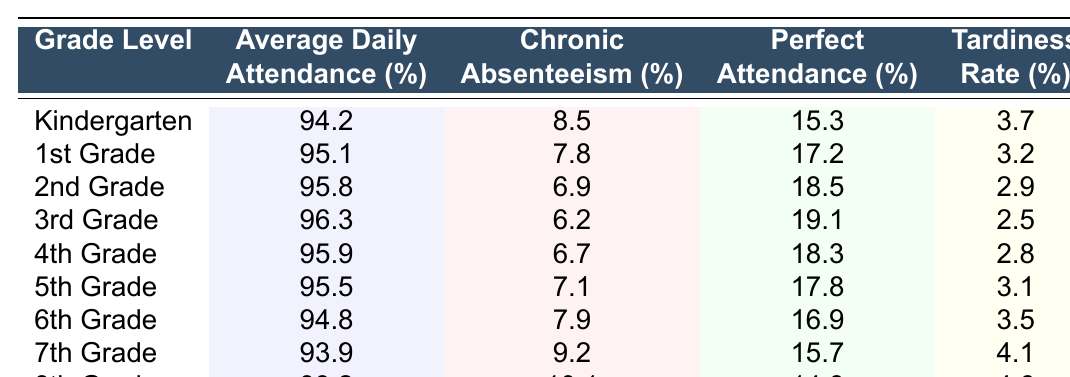What is the average daily attendance percentage for 3rd grade? The table shows that the average daily attendance for 3rd grade is listed directly under the “Average Daily Attendance (%)” column for that row, which is 96.3%.
Answer: 96.3% Which grade level has the highest perfect attendance percentage? By inspecting the “Perfect Attendance (%)” column, we find that 3rd grade has the highest percentage at 19.1%.
Answer: 3rd Grade What is the chronic absenteeism percentage for 2nd grade? The chronic absenteeism percentage for 2nd grade can be found directly in the “Chronic Absenteeism (%)” column for that row, which is 6.9%.
Answer: 6.9% Is the average daily attendance for 8th grade above 94%? By checking the “Average Daily Attendance (%)” column for 8th grade, the value is 93.2%, which is below 94%.
Answer: No What is the difference in perfect attendance percentage between 1st grade and 5th grade? The perfect attendance percentage for 1st grade is 17.2% and for 5th grade is 17.8%. To find the difference, we calculate 17.8% - 17.2% = 0.6%.
Answer: 0.6% Which grade has the highest tardiness rate? By looking at the “Tardiness Rate (%)” column, 8th grade has the highest rate at 4.6%.
Answer: 8th Grade What is the average chronic absenteeism percentage across all grades? To find the average chronic absenteeism, we sum the percentages (8.5 + 7.8 + 6.9 + 6.2 + 6.7 + 7.1 + 7.9 + 9.2 + 10.1) = 70.4% and divide by the number of grades (9), which gives us 70.4% / 9 ≈ 7.82%.
Answer: 7.82% Which grade level has a higher average daily attendance, 6th grade or 7th grade? The average daily attendance for 6th grade is 94.8% and for 7th grade it is 93.9%. Since 94.8% is greater than 93.9%, 6th grade has a higher attendance.
Answer: 6th Grade What is the overall trend of perfect attendance percentages from Kindergarten through 8th grade? By reviewing the "Perfect Attendance (%)" values from Kindergarten (15.3%) to 8th grade (14.8%), we observe a decreasing trend in perfect attendance percentages.
Answer: Decreasing Trend What is the combined average of average daily attendance percentages for lower grades (Kindergarten to 5th grade)? To find the average for lower grades, sum their percentages (94.2 + 95.1 + 95.8 + 96.3 + 95.9) = 477.3% and divide by 5: 477.3% / 5 = 95.46%.
Answer: 95.46% 